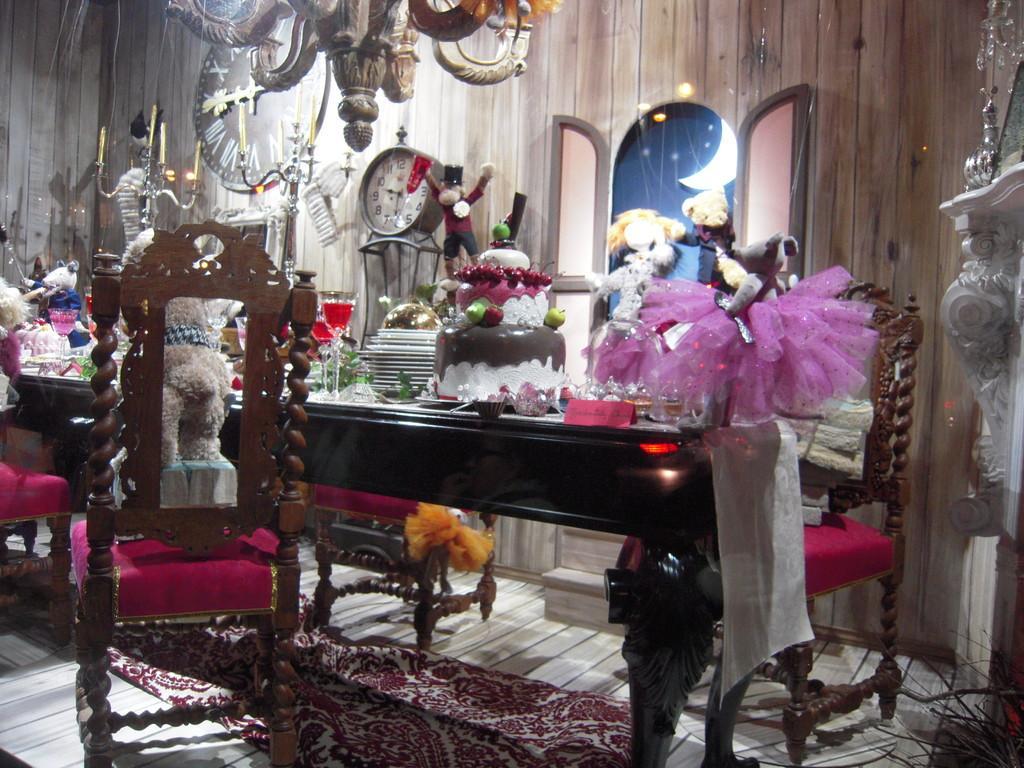How would you summarize this image in a sentence or two? In this image there is a chair having a doll in it. Beside there is a table having a cake, glasses and few objects on it. Behind the table there are few chairs. A clock is on the stand. Left side there are few candles on the stand. There are few toys on the table. Background there is a wooden there's a wall having a window. Top of the image there is a chandelier. 